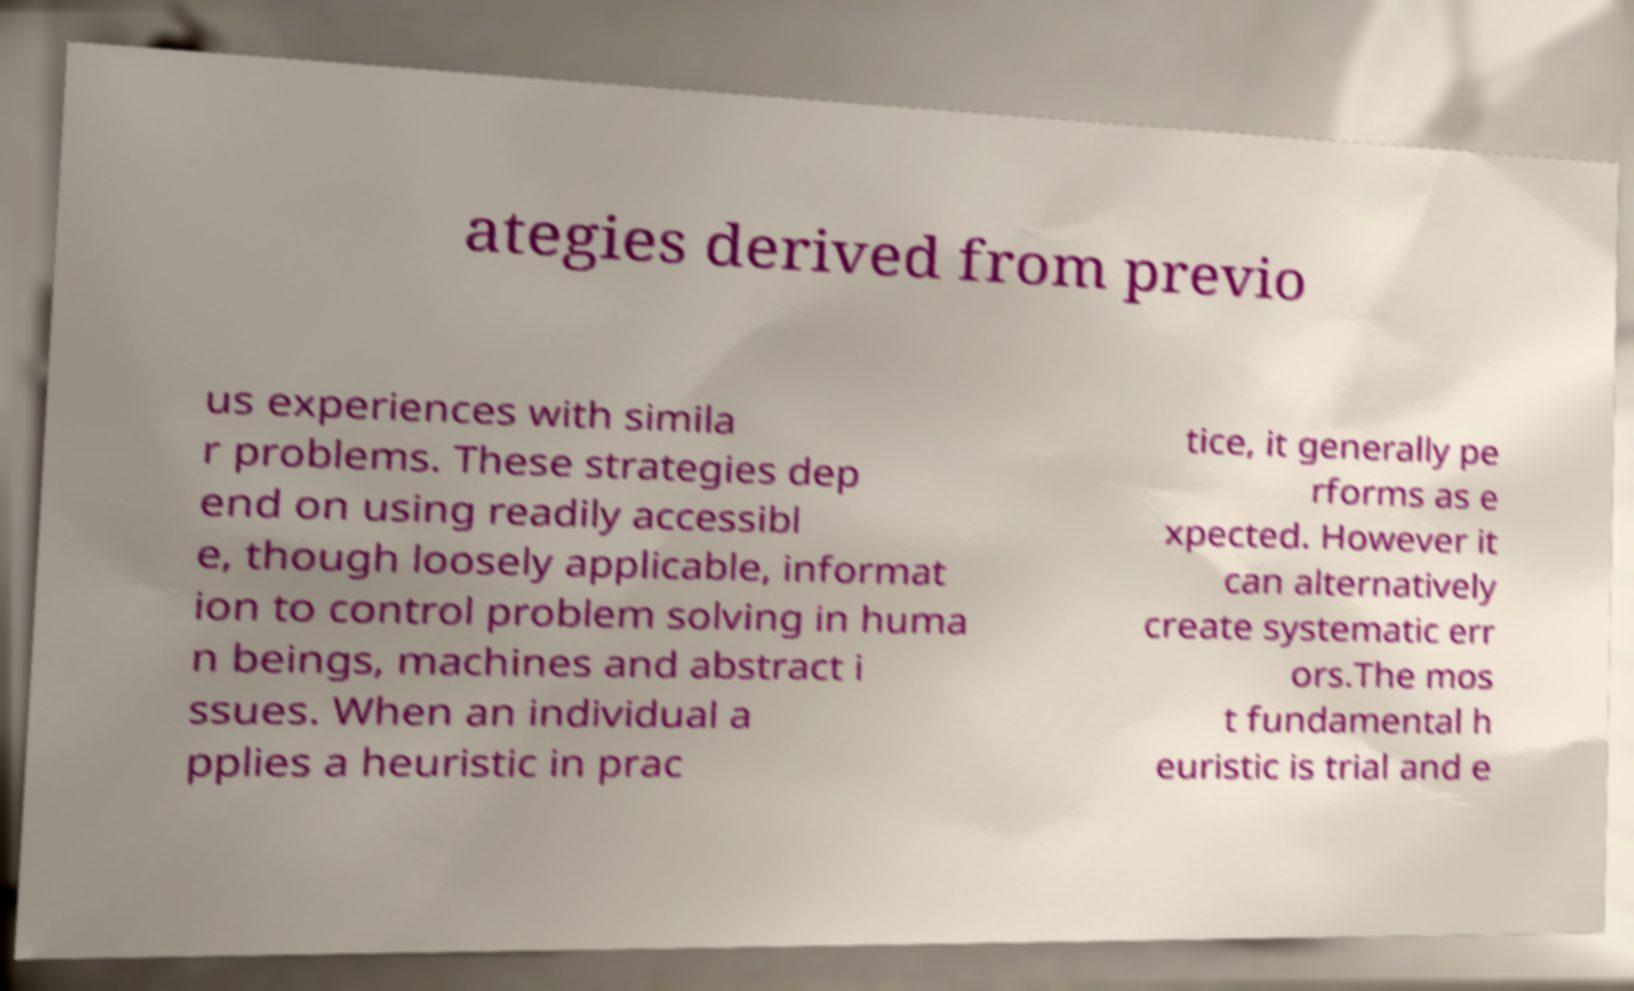I need the written content from this picture converted into text. Can you do that? ategies derived from previo us experiences with simila r problems. These strategies dep end on using readily accessibl e, though loosely applicable, informat ion to control problem solving in huma n beings, machines and abstract i ssues. When an individual a pplies a heuristic in prac tice, it generally pe rforms as e xpected. However it can alternatively create systematic err ors.The mos t fundamental h euristic is trial and e 